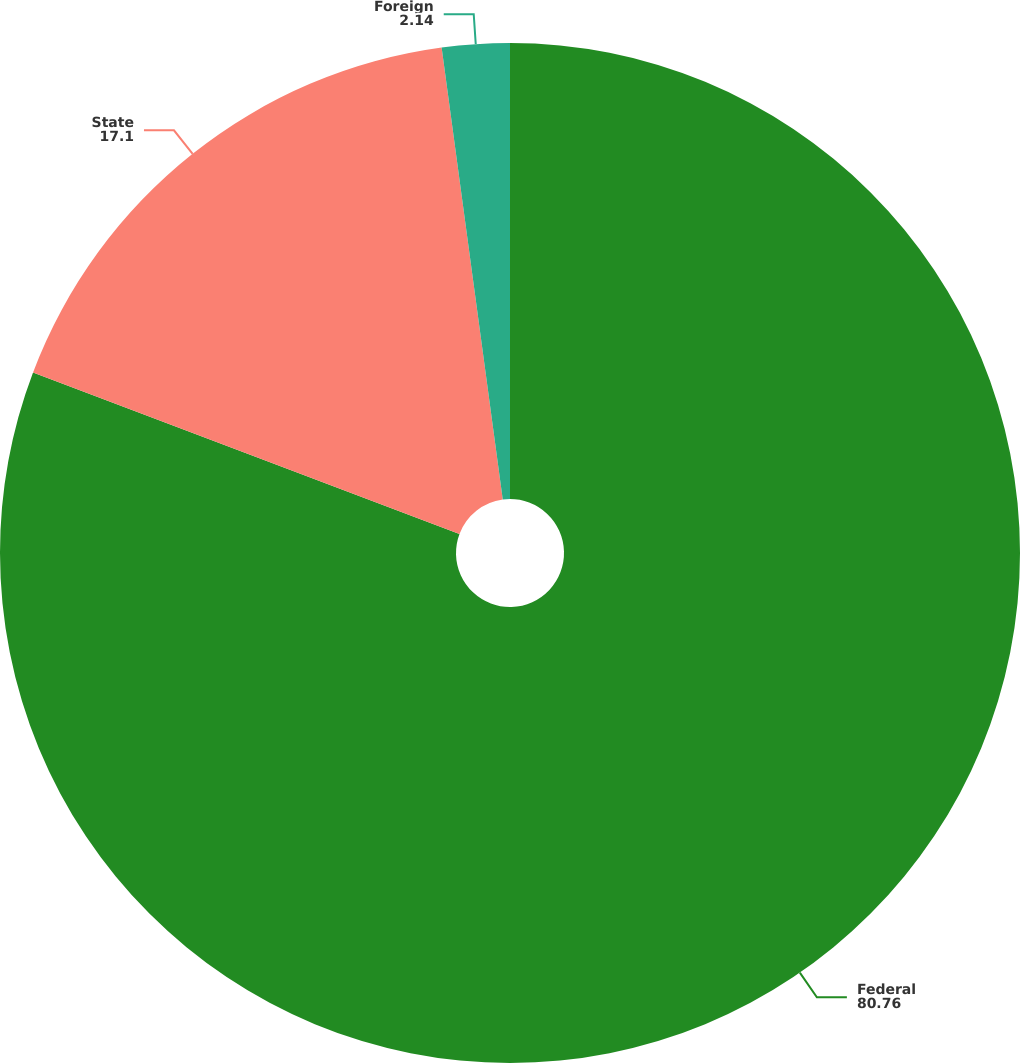Convert chart to OTSL. <chart><loc_0><loc_0><loc_500><loc_500><pie_chart><fcel>Federal<fcel>State<fcel>Foreign<nl><fcel>80.76%<fcel>17.1%<fcel>2.14%<nl></chart> 